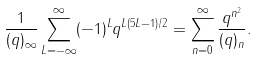<formula> <loc_0><loc_0><loc_500><loc_500>\frac { 1 } { ( q ) _ { \infty } } \sum _ { L = - \infty } ^ { \infty } ( - 1 ) ^ { L } q ^ { L ( 5 L - 1 ) / 2 } = \sum _ { n = 0 } ^ { \infty } \frac { q ^ { n ^ { 2 } } } { ( q ) _ { n } } .</formula> 